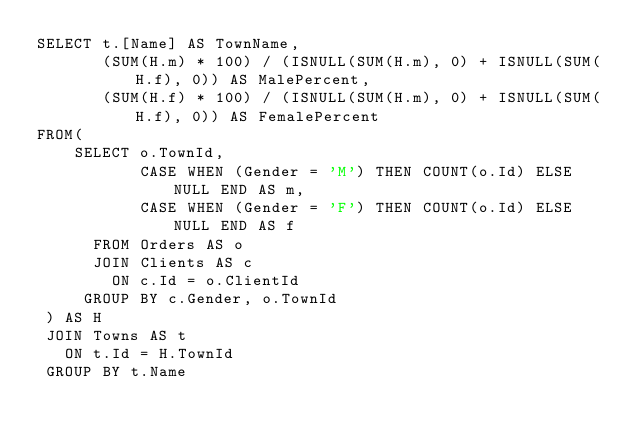<code> <loc_0><loc_0><loc_500><loc_500><_SQL_>SELECT t.[Name] AS TownName,
	   (SUM(H.m) * 100) / (ISNULL(SUM(H.m), 0) + ISNULL(SUM(H.f), 0)) AS MalePercent,
	   (SUM(H.f) * 100) / (ISNULL(SUM(H.m), 0) + ISNULL(SUM(H.f), 0)) AS FemalePercent
FROM(
	SELECT o.TownId, 
		   CASE WHEN (Gender = 'M') THEN COUNT(o.Id) ELSE NULL END AS m,
		   CASE WHEN (Gender = 'F') THEN COUNT(o.Id) ELSE NULL END AS f
	  FROM Orders AS o
	  JOIN Clients AS c
		ON c.Id = o.ClientId
	 GROUP BY c.Gender, o.TownId
 ) AS H
 JOIN Towns AS t
   ON t.Id = H.TownId
 GROUP BY t.Name</code> 